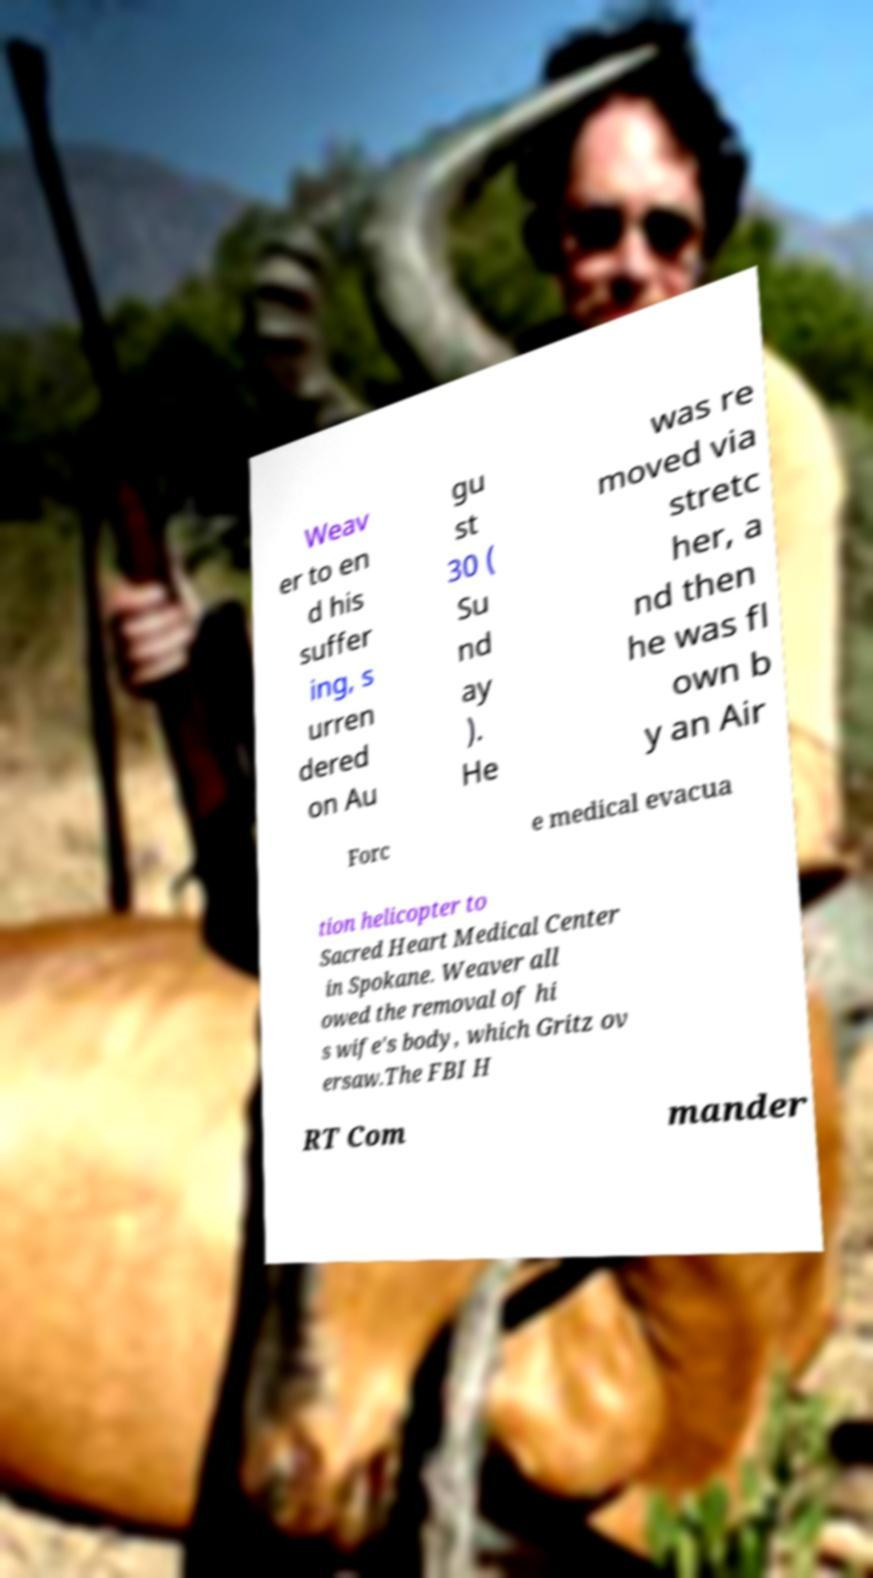Can you read and provide the text displayed in the image?This photo seems to have some interesting text. Can you extract and type it out for me? Weav er to en d his suffer ing, s urren dered on Au gu st 30 ( Su nd ay ). He was re moved via stretc her, a nd then he was fl own b y an Air Forc e medical evacua tion helicopter to Sacred Heart Medical Center in Spokane. Weaver all owed the removal of hi s wife's body, which Gritz ov ersaw.The FBI H RT Com mander 